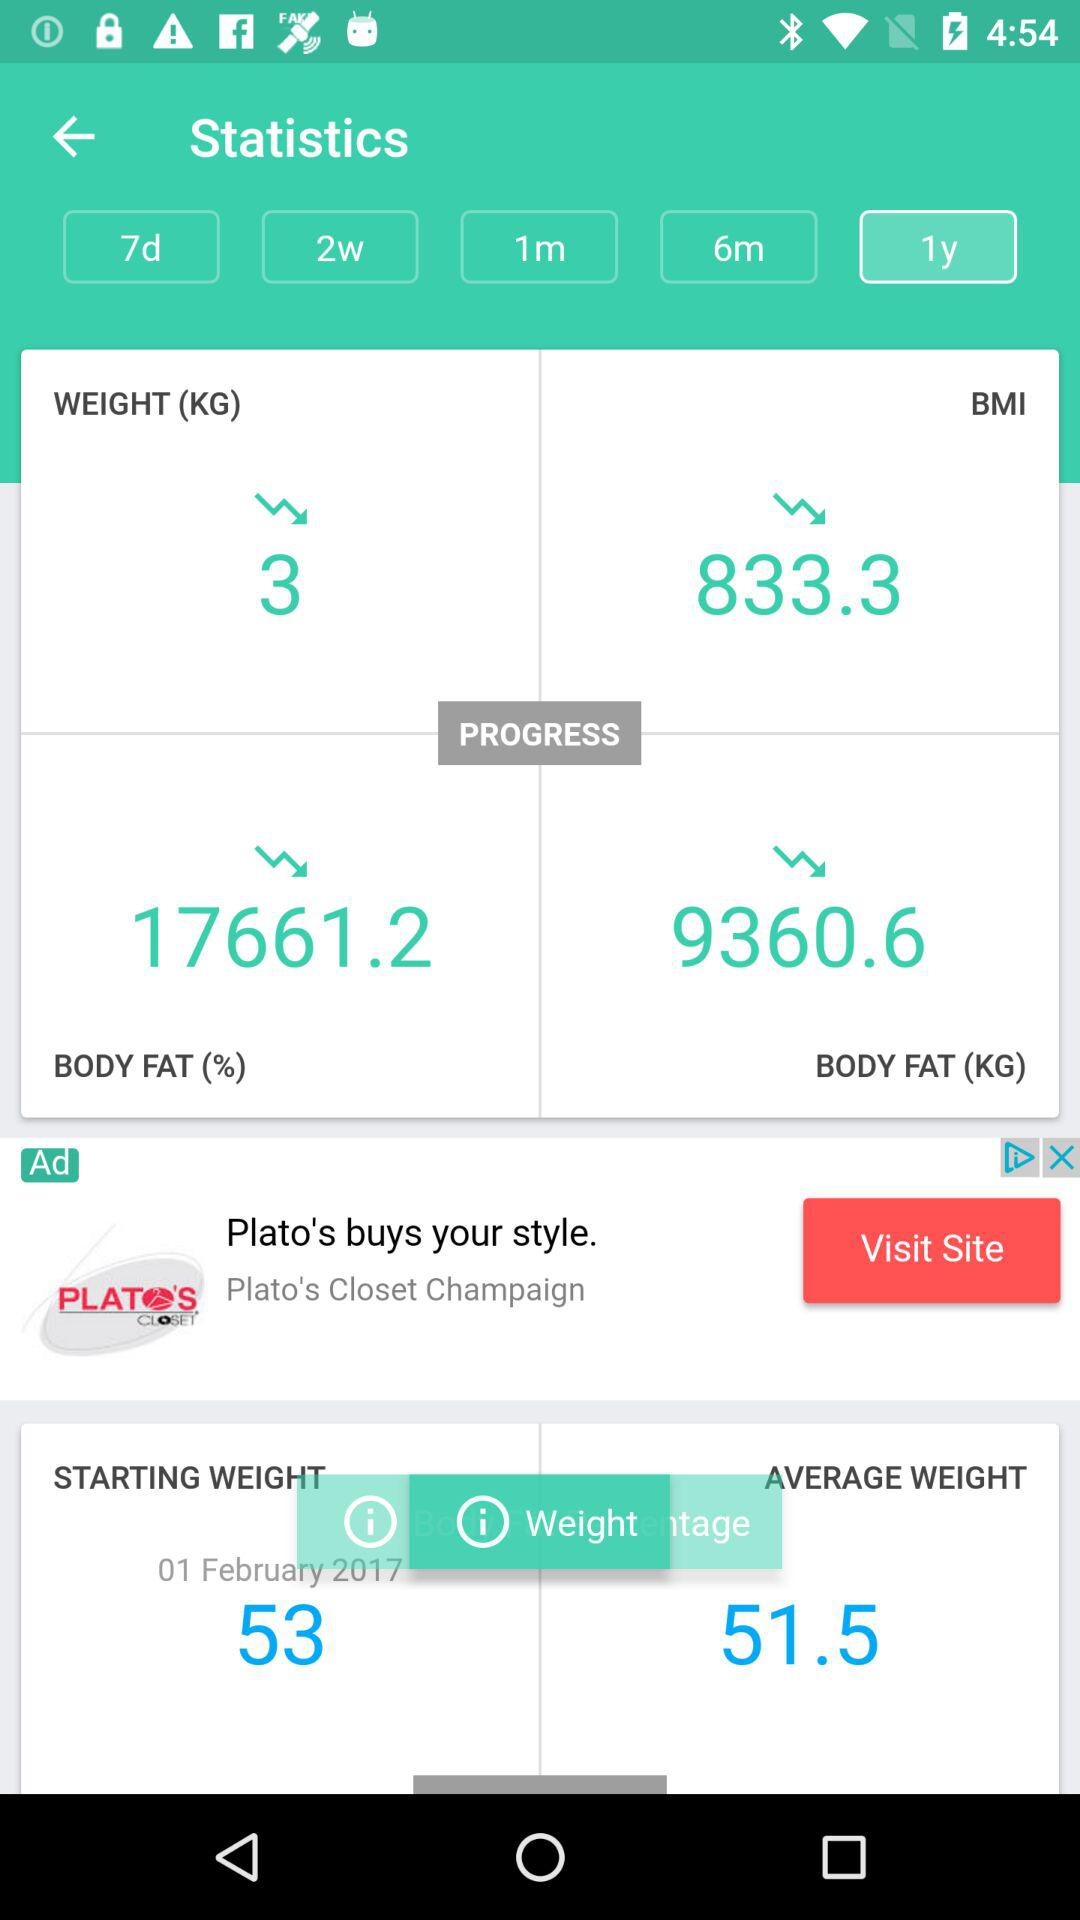How much body fat has decreased in percentage? The body fat percentage has decreased to 17661.2. 